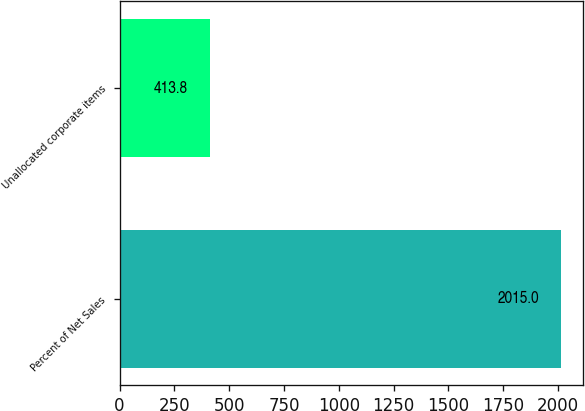<chart> <loc_0><loc_0><loc_500><loc_500><bar_chart><fcel>Percent of Net Sales<fcel>Unallocated corporate items<nl><fcel>2015<fcel>413.8<nl></chart> 